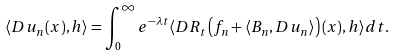<formula> <loc_0><loc_0><loc_500><loc_500>\langle D u _ { n } ( x ) , h \rangle = \int _ { 0 } ^ { \infty } e ^ { - \lambda t } \langle D R _ { t } \left ( f _ { n } + \langle B _ { n } , D u _ { n } \rangle \right ) ( x ) , h \rangle d t .</formula> 